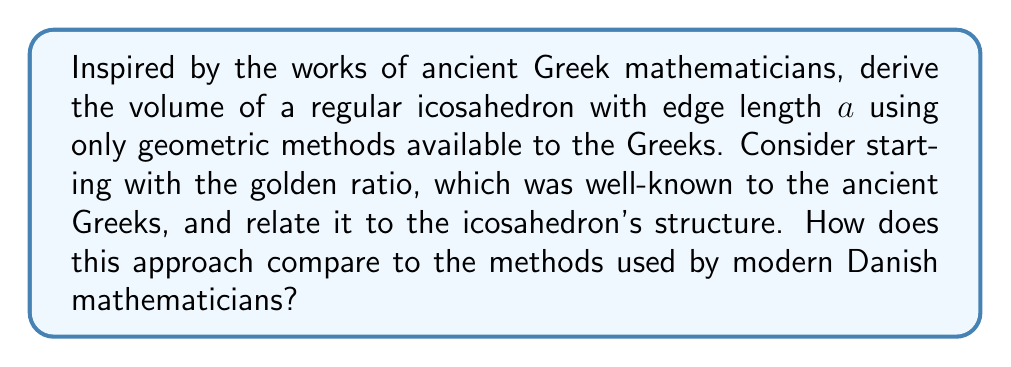Could you help me with this problem? Let's approach this problem using methods that would have been available to ancient Greek mathematicians:

1) First, recall that the golden ratio, $\phi = \frac{1+\sqrt{5}}{2}$, was well-known to the Greeks. This ratio is intimately connected to the icosahedron's structure.

2) Consider an icosahedron inscribed in a sphere. The distance from the center of the icosahedron to any vertex is the radius $R$ of this sphere.

3) If we draw lines from the center to all vertices, we create 20 congruent triangular pyramids. The volume of the icosahedron will be the sum of these pyramids' volumes.

4) In each pyramid, the base is a face of the icosahedron (an equilateral triangle), and the height is the perpendicular distance from the center to this face.

5) Let's call this height $h$. We can find $h$ using the Pythagorean theorem:

   $$R^2 = h^2 + (\frac{a\sqrt{3}}{3})^2$$

   where $\frac{a\sqrt{3}}{3}$ is the radius of the circumcircle of the equilateral triangular face.

6) Now, we need to relate $R$ to $a$. In an icosahedron, the ratio of the distance between opposite vertices to the edge length is $\phi$. The distance between opposite vertices is $2R$, so:

   $$\frac{2R}{a} = \phi = \frac{1+\sqrt{5}}{2}$$

7) Solving for $R$:

   $$R = \frac{a(1+\sqrt{5})}{4}$$

8) Substituting this into the Pythagorean theorem from step 5:

   $$(\frac{a(1+\sqrt{5})}{4})^2 = h^2 + (\frac{a\sqrt{3}}{3})^2$$

9) Solving for $h$:

   $$h = \frac{a}{12}\sqrt{10+2\sqrt{5}}$$

10) The volume of each pyramidal piece is $\frac{1}{3} \times$ (area of base) $\times$ height:

    $$V_{pyramid} = \frac{1}{3} \times \frac{\sqrt{3}}{4}a^2 \times \frac{a}{12}\sqrt{10+2\sqrt{5}}$$

11) The total volume is 20 times this:

    $$V_{icosahedron} = 20 \times \frac{1}{3} \times \frac{\sqrt{3}}{4}a^2 \times \frac{a}{12}\sqrt{10+2\sqrt{5}}$$

12) Simplifying:

    $$V_{icosahedron} = \frac{5}{12}(3+\sqrt{5})a^3$$

This approach, using geometric reasoning and the golden ratio, is in line with ancient Greek mathematical methods. Modern Danish mathematicians might approach this problem using more advanced techniques like vector algebra or differential geometry, but the beauty of this geometric method lies in its elegance and its connection to ancient mathematical thought.
Answer: $$V_{icosahedron} = \frac{5}{12}(3+\sqrt{5})a^3$$
where $a$ is the edge length of the icosahedron. 